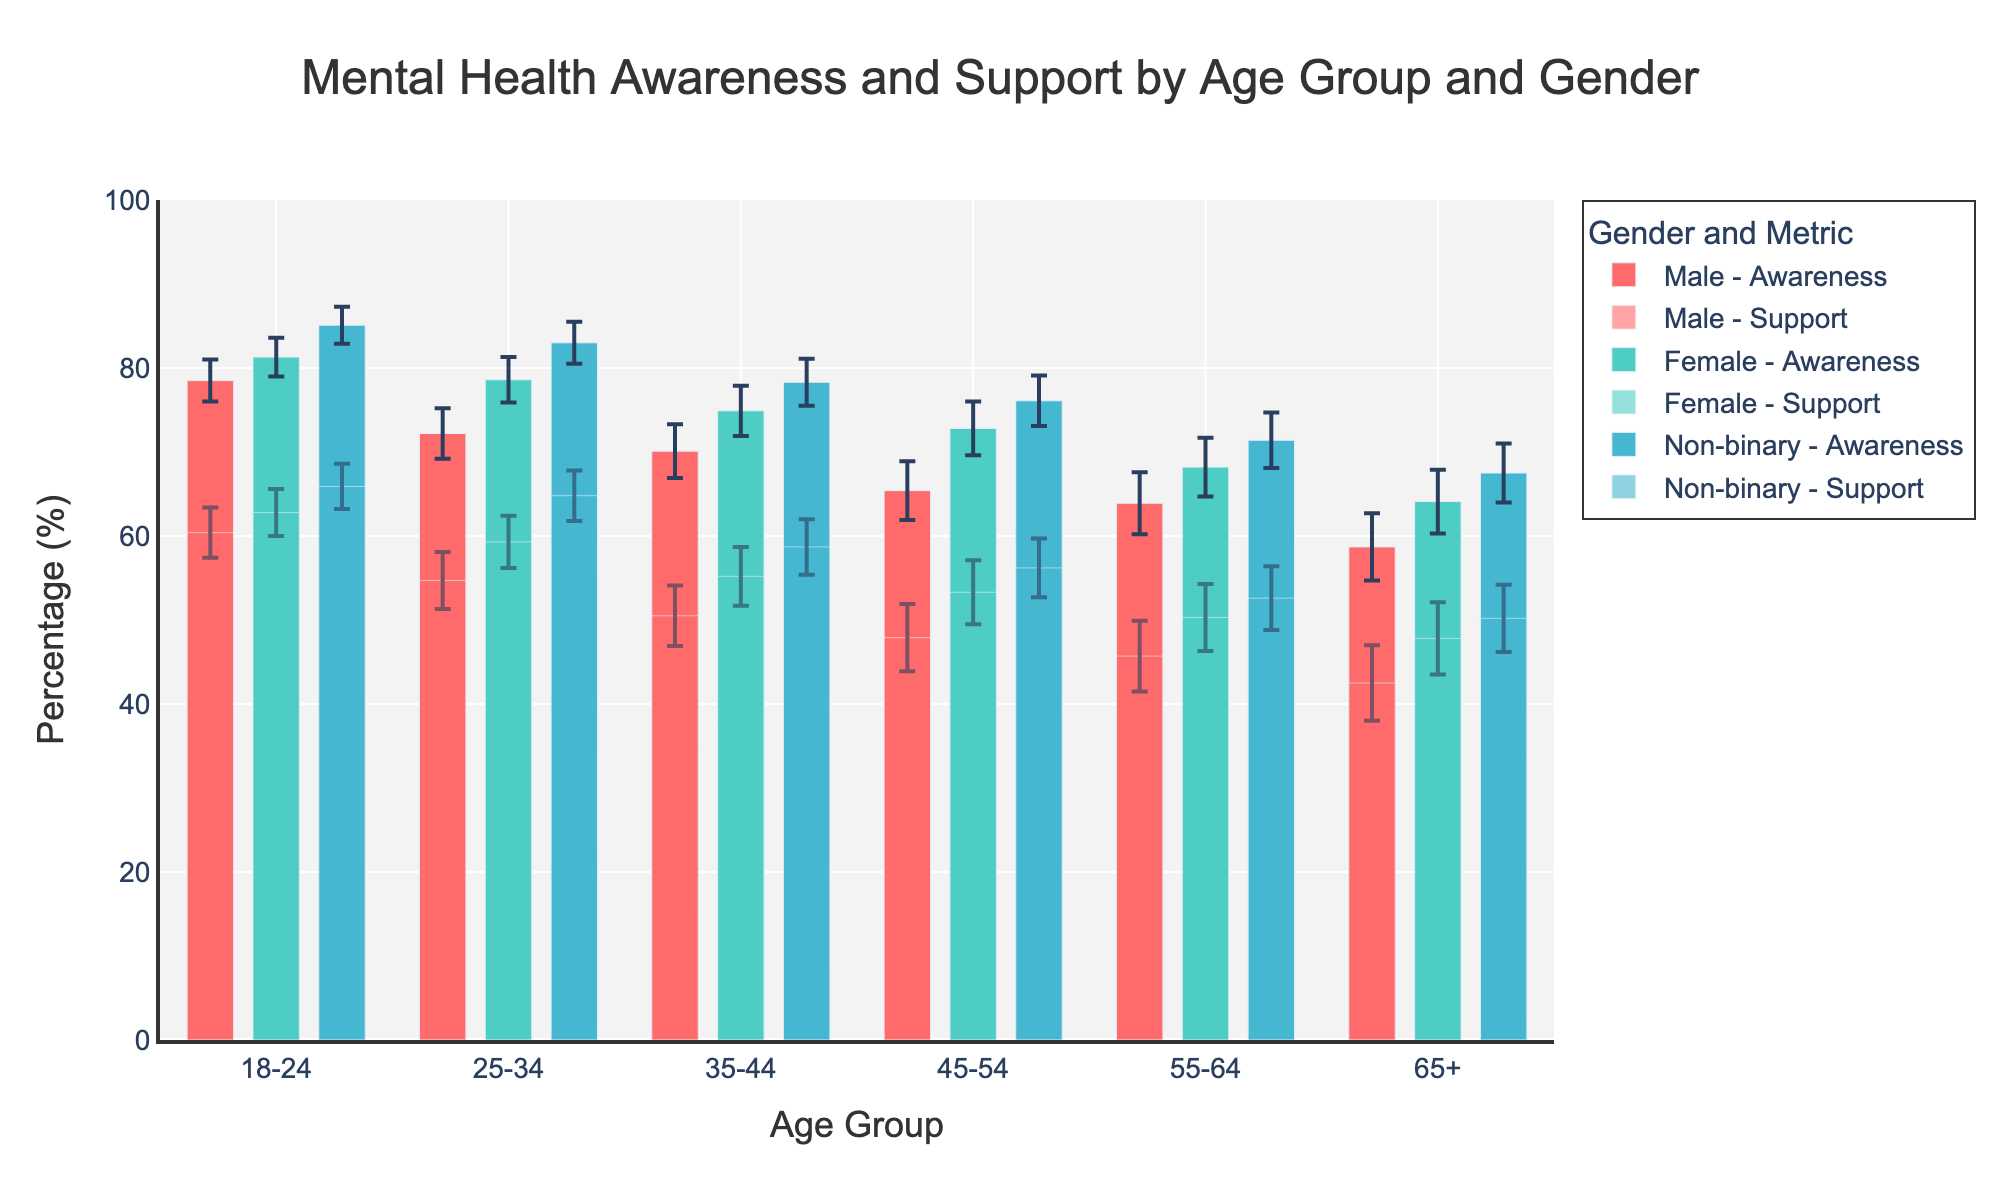What is the title of the figure? The title is usually positioned at the top of the figure. In this case, it is clearly stated just above the chart area.
Answer: Mental Health Awareness and Support by Age Group and Gender Which gender has the highest mental health awareness in the age group of 18-24? To determine this, look at the bars representing 'Mental Health Awareness' for each gender in the 18-24 age group. The bar for 'Non-binary' is the highest.
Answer: Non-binary What is the Mental Health Support percentage for females aged 25-34? Locate the bar representing 'Female - Support' in the 25-34 age group. Read the value directly from the y-axis.
Answer: 59.3% Compare the mental health awareness percentages for males and females aged 55-64. Who has a higher percentage and by how much? Find the 'Awareness' bars for males and females in the 55-64 age group. Subtract the male percentage from the female percentage to find the difference. Females have 68.2% and males have 63.9%, so the difference is 4.3%.
Answer: Female, by 4.3% For the 35-44 age group, which gender has the smallest error margin for mental health awareness? Look at the error bars associated with 'Awareness' data for each gender in the 35-44 age group. 'Non-binary' has the smallest error margin.
Answer: Non-binary What is the difference in mental health support percentages between non-binary individuals aged 45-54 and non-binary individuals aged 35-44? Identify the 'Support' bars for non-binary individuals in both age groups. Subtract the value for the 35-44 group from the value for the 45-54 group: 56.2% - 58.7% = -2.5%.
Answer: -2.5% How do the error margins for mental health support compare between males and females aged 65+? Locate the error bars for 'Support' data for males and females in the 65+ age group. The error margin is 4.5% for males and 4.3% for females. Compare these values.
Answer: Males have a 0.2% larger error margin than females Which age group shows the highest mental health awareness percentage for males? Check all the age groups for the 'Male - Awareness' bars and identify the highest one. The 18-24 age group shows the highest value for males at 78.5%.
Answer: 18-24 What is the overall trend in mental health support percentages by age group? Observe the 'Support' bars across all age groups. Generally, mental health support percentages decrease as age increases, with some fluctuations.
Answer: Decreasing trend with age 